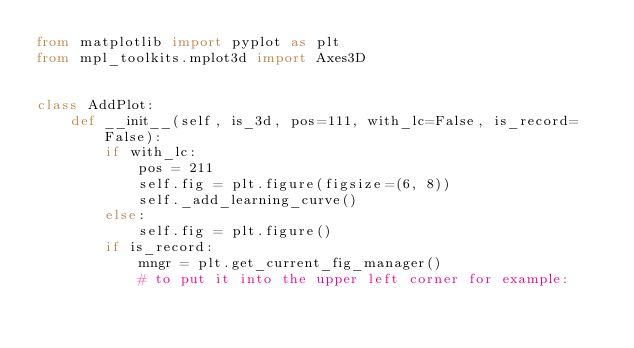Convert code to text. <code><loc_0><loc_0><loc_500><loc_500><_Python_>from matplotlib import pyplot as plt
from mpl_toolkits.mplot3d import Axes3D


class AddPlot:
    def __init__(self, is_3d, pos=111, with_lc=False, is_record=False):
        if with_lc:
            pos = 211
            self.fig = plt.figure(figsize=(6, 8))
            self._add_learning_curve()
        else:
            self.fig = plt.figure()
        if is_record:
            mngr = plt.get_current_fig_manager()
            # to put it into the upper left corner for example:</code> 